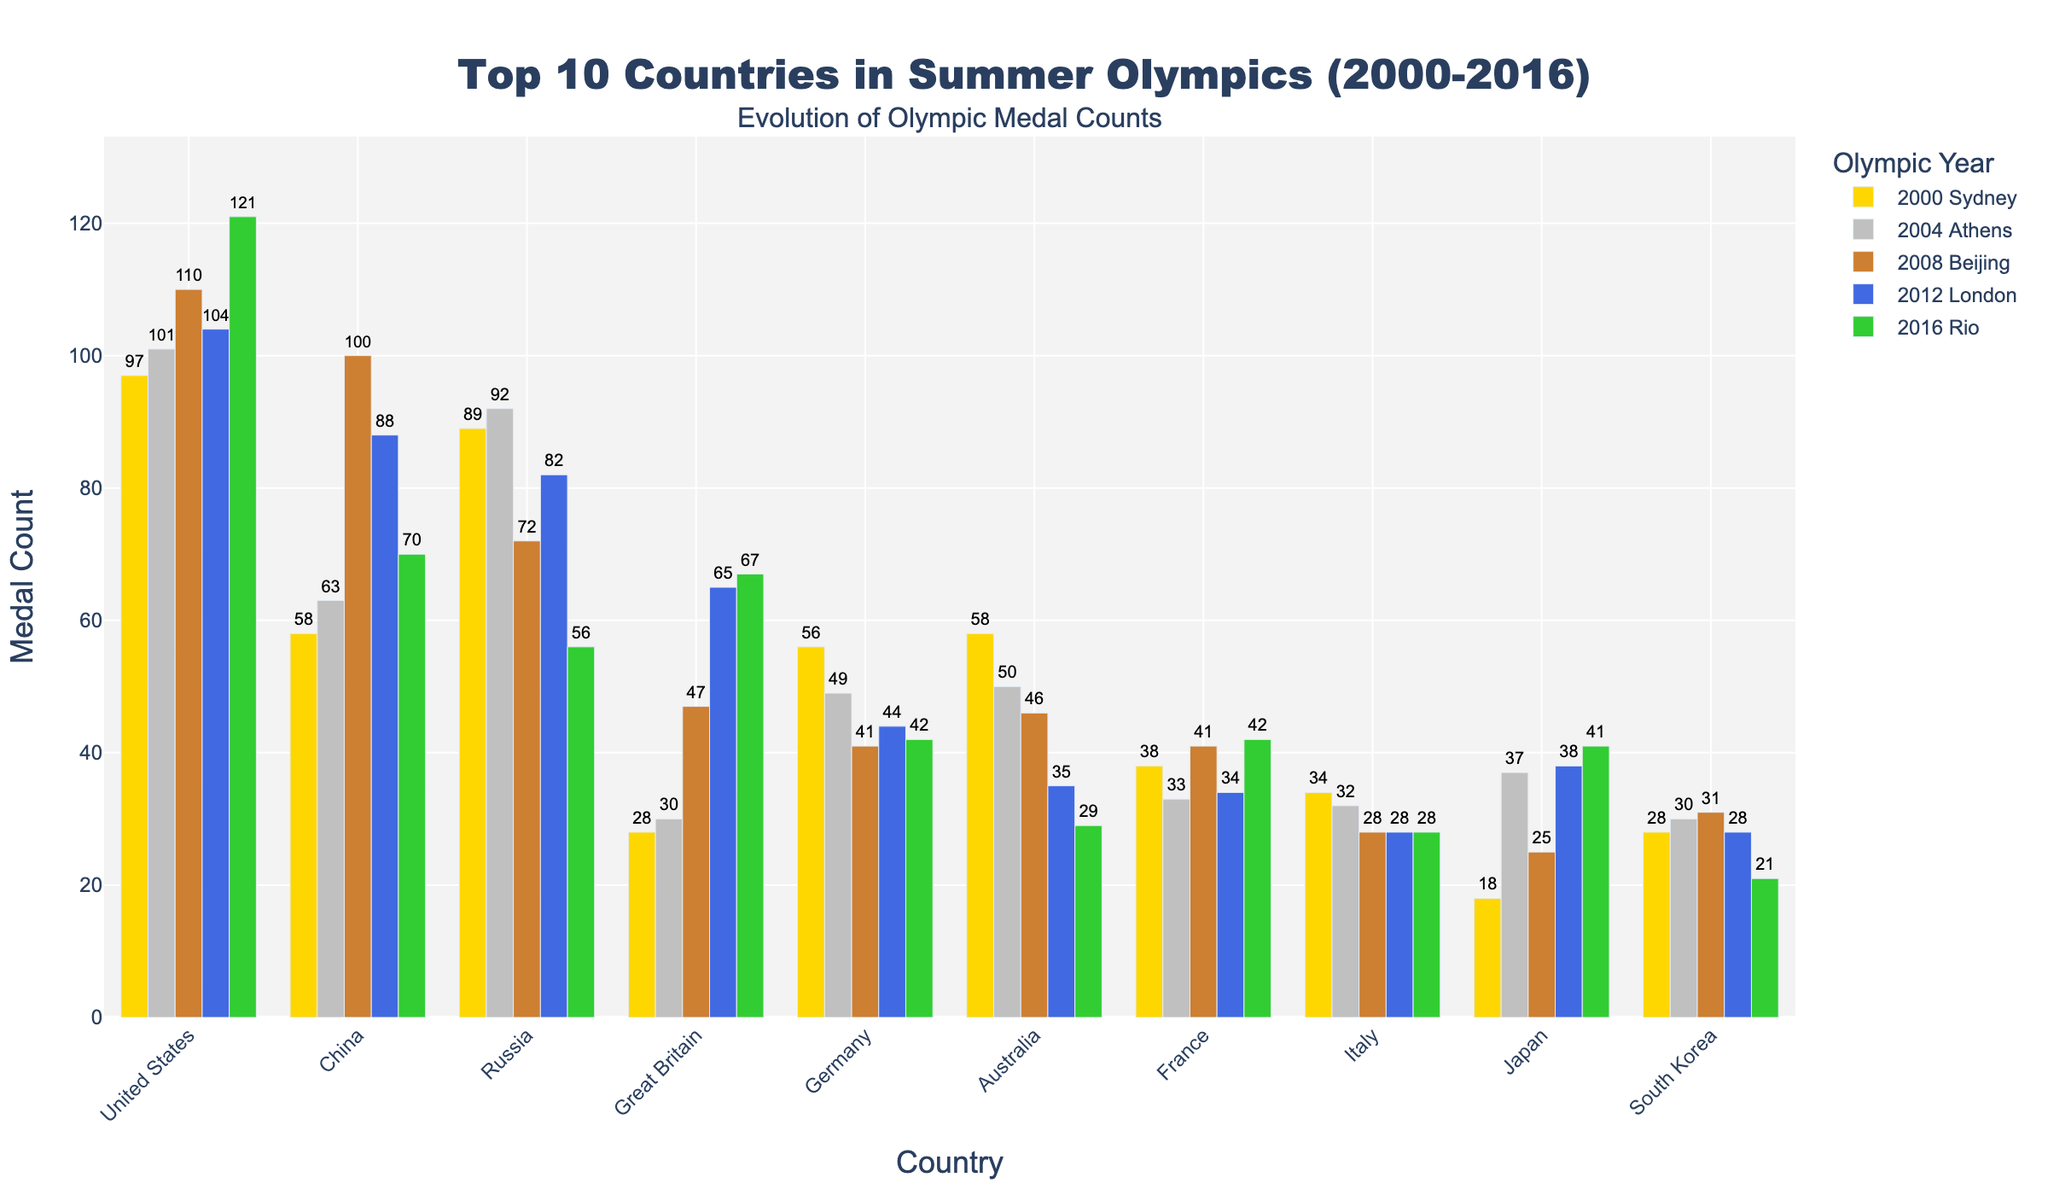What country earned the most medals in 2008 Beijing? By looking at the bars representing 2008 Beijing, the tallest bar is for the "United States", indicating they earned the most medals.
Answer: United States Which country showed the most significant drop in medal count from 2008 Beijing to 2016 Rio? By comparing the heights of the bars for these years, it's evident that "China" had the highest drop, from 100 in 2008 to 70 in 2016, a decrease of 30 medals.
Answer: China What's the total number of medals won by Great Britain over the 5 Summer Olympics? Sum the values for Great Britain: 28 (2000) + 30 (2004) + 47 (2008) + 65 (2012) + 67 (2016) = 237.
Answer: 237 Which countries had an increase in medal count from 2004 Athens to 2008 Beijing? By examining the heights of the bars, the countries with increasing bar heights are "United States", "China", "Great Britain", "Germany", and "South Korea".
Answer: United States, China, Great Britain, Germany, South Korea In which year did Japan win the most medals? By comparing the bar heights for Japan across all years, the tallest bar is for 2016 Rio, where Japan won 41 medals.
Answer: 2016 Rio Comparing 2012 London and 2016 Rio, which year had the highest total medal count for all countries combined? Sum the counts for each year: 2012 London (104+88+82+65+44+35+34+28+38+28 = 546) vs. 2016 Rio (121+70+56+67+42+29+42+28+41+21 = 517). 2012 London has a higher total.
Answer: 2012 London What was the average medal count for Australia over the 5 Summer Olympics? Calculate the average: (58 + 50 + 46 + 35 + 29) / 5 = 43.6.
Answer: 43.6 Which country won fewer medals in 2016 Rio compared to 2000 Sydney? By comparing bar heights for these years, "Russia", "Germany", "Australia", and "South Korea" won fewer medals in 2016 Rio compared to 2000 Sydney.
Answer: Russia, Germany, Australia, South Korea Identify the countries that had a consistent medal count (same number) in any two of the given Summer Olympics. By looking for consistent bar heights, "Italy" had 28 medals in 2008, 2012, and 2016 (three consecutive Olympics).
Answer: Italy For which country did the medal count increase the most between any two consecutive Summer Olympics? By examining changes in bar heights, "United States" had the highest increase between 2012 and 2016, from 104 to 121, an increase of 17 medals.
Answer: United States 